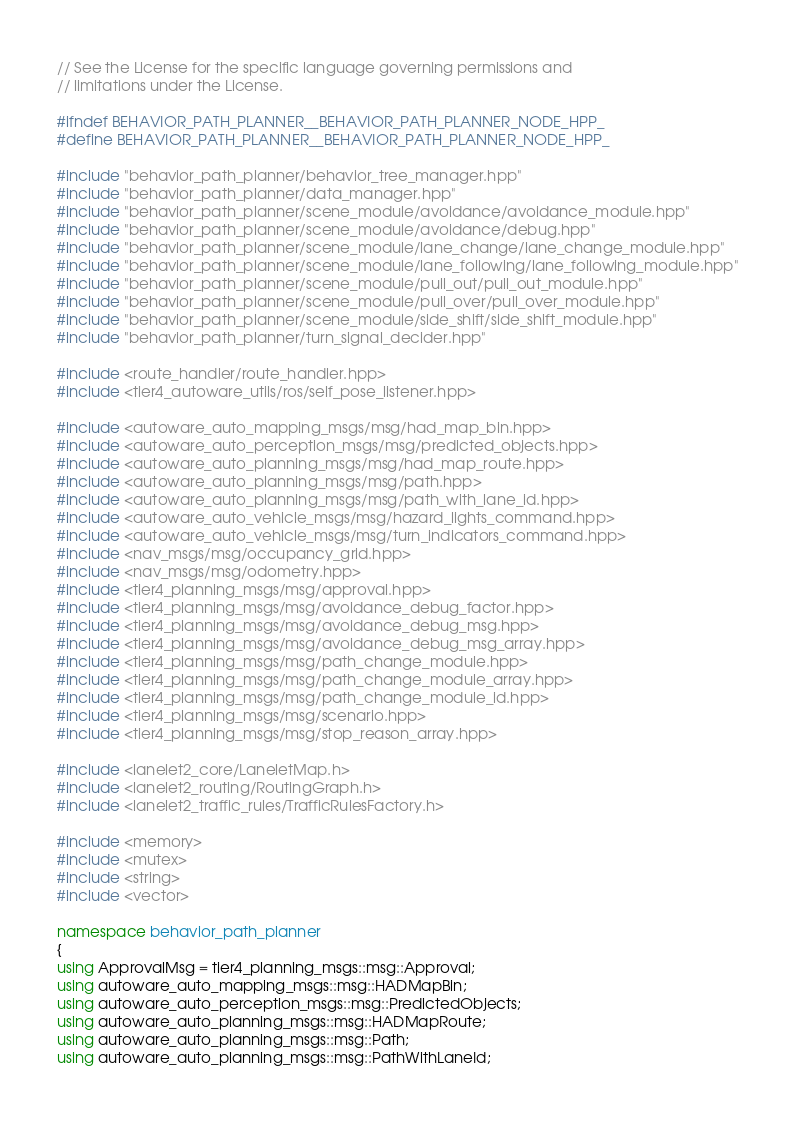<code> <loc_0><loc_0><loc_500><loc_500><_C++_>// See the License for the specific language governing permissions and
// limitations under the License.

#ifndef BEHAVIOR_PATH_PLANNER__BEHAVIOR_PATH_PLANNER_NODE_HPP_
#define BEHAVIOR_PATH_PLANNER__BEHAVIOR_PATH_PLANNER_NODE_HPP_

#include "behavior_path_planner/behavior_tree_manager.hpp"
#include "behavior_path_planner/data_manager.hpp"
#include "behavior_path_planner/scene_module/avoidance/avoidance_module.hpp"
#include "behavior_path_planner/scene_module/avoidance/debug.hpp"
#include "behavior_path_planner/scene_module/lane_change/lane_change_module.hpp"
#include "behavior_path_planner/scene_module/lane_following/lane_following_module.hpp"
#include "behavior_path_planner/scene_module/pull_out/pull_out_module.hpp"
#include "behavior_path_planner/scene_module/pull_over/pull_over_module.hpp"
#include "behavior_path_planner/scene_module/side_shift/side_shift_module.hpp"
#include "behavior_path_planner/turn_signal_decider.hpp"

#include <route_handler/route_handler.hpp>
#include <tier4_autoware_utils/ros/self_pose_listener.hpp>

#include <autoware_auto_mapping_msgs/msg/had_map_bin.hpp>
#include <autoware_auto_perception_msgs/msg/predicted_objects.hpp>
#include <autoware_auto_planning_msgs/msg/had_map_route.hpp>
#include <autoware_auto_planning_msgs/msg/path.hpp>
#include <autoware_auto_planning_msgs/msg/path_with_lane_id.hpp>
#include <autoware_auto_vehicle_msgs/msg/hazard_lights_command.hpp>
#include <autoware_auto_vehicle_msgs/msg/turn_indicators_command.hpp>
#include <nav_msgs/msg/occupancy_grid.hpp>
#include <nav_msgs/msg/odometry.hpp>
#include <tier4_planning_msgs/msg/approval.hpp>
#include <tier4_planning_msgs/msg/avoidance_debug_factor.hpp>
#include <tier4_planning_msgs/msg/avoidance_debug_msg.hpp>
#include <tier4_planning_msgs/msg/avoidance_debug_msg_array.hpp>
#include <tier4_planning_msgs/msg/path_change_module.hpp>
#include <tier4_planning_msgs/msg/path_change_module_array.hpp>
#include <tier4_planning_msgs/msg/path_change_module_id.hpp>
#include <tier4_planning_msgs/msg/scenario.hpp>
#include <tier4_planning_msgs/msg/stop_reason_array.hpp>

#include <lanelet2_core/LaneletMap.h>
#include <lanelet2_routing/RoutingGraph.h>
#include <lanelet2_traffic_rules/TrafficRulesFactory.h>

#include <memory>
#include <mutex>
#include <string>
#include <vector>

namespace behavior_path_planner
{
using ApprovalMsg = tier4_planning_msgs::msg::Approval;
using autoware_auto_mapping_msgs::msg::HADMapBin;
using autoware_auto_perception_msgs::msg::PredictedObjects;
using autoware_auto_planning_msgs::msg::HADMapRoute;
using autoware_auto_planning_msgs::msg::Path;
using autoware_auto_planning_msgs::msg::PathWithLaneId;</code> 